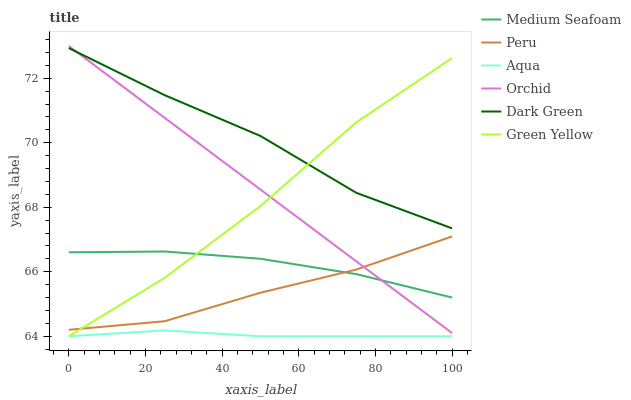Does Aqua have the minimum area under the curve?
Answer yes or no. Yes. Does Dark Green have the maximum area under the curve?
Answer yes or no. Yes. Does Peru have the minimum area under the curve?
Answer yes or no. No. Does Peru have the maximum area under the curve?
Answer yes or no. No. Is Orchid the smoothest?
Answer yes or no. Yes. Is Green Yellow the roughest?
Answer yes or no. Yes. Is Aqua the smoothest?
Answer yes or no. No. Is Aqua the roughest?
Answer yes or no. No. Does Aqua have the lowest value?
Answer yes or no. Yes. Does Peru have the lowest value?
Answer yes or no. No. Does Orchid have the highest value?
Answer yes or no. Yes. Does Peru have the highest value?
Answer yes or no. No. Is Aqua less than Peru?
Answer yes or no. Yes. Is Dark Green greater than Medium Seafoam?
Answer yes or no. Yes. Does Green Yellow intersect Dark Green?
Answer yes or no. Yes. Is Green Yellow less than Dark Green?
Answer yes or no. No. Is Green Yellow greater than Dark Green?
Answer yes or no. No. Does Aqua intersect Peru?
Answer yes or no. No. 